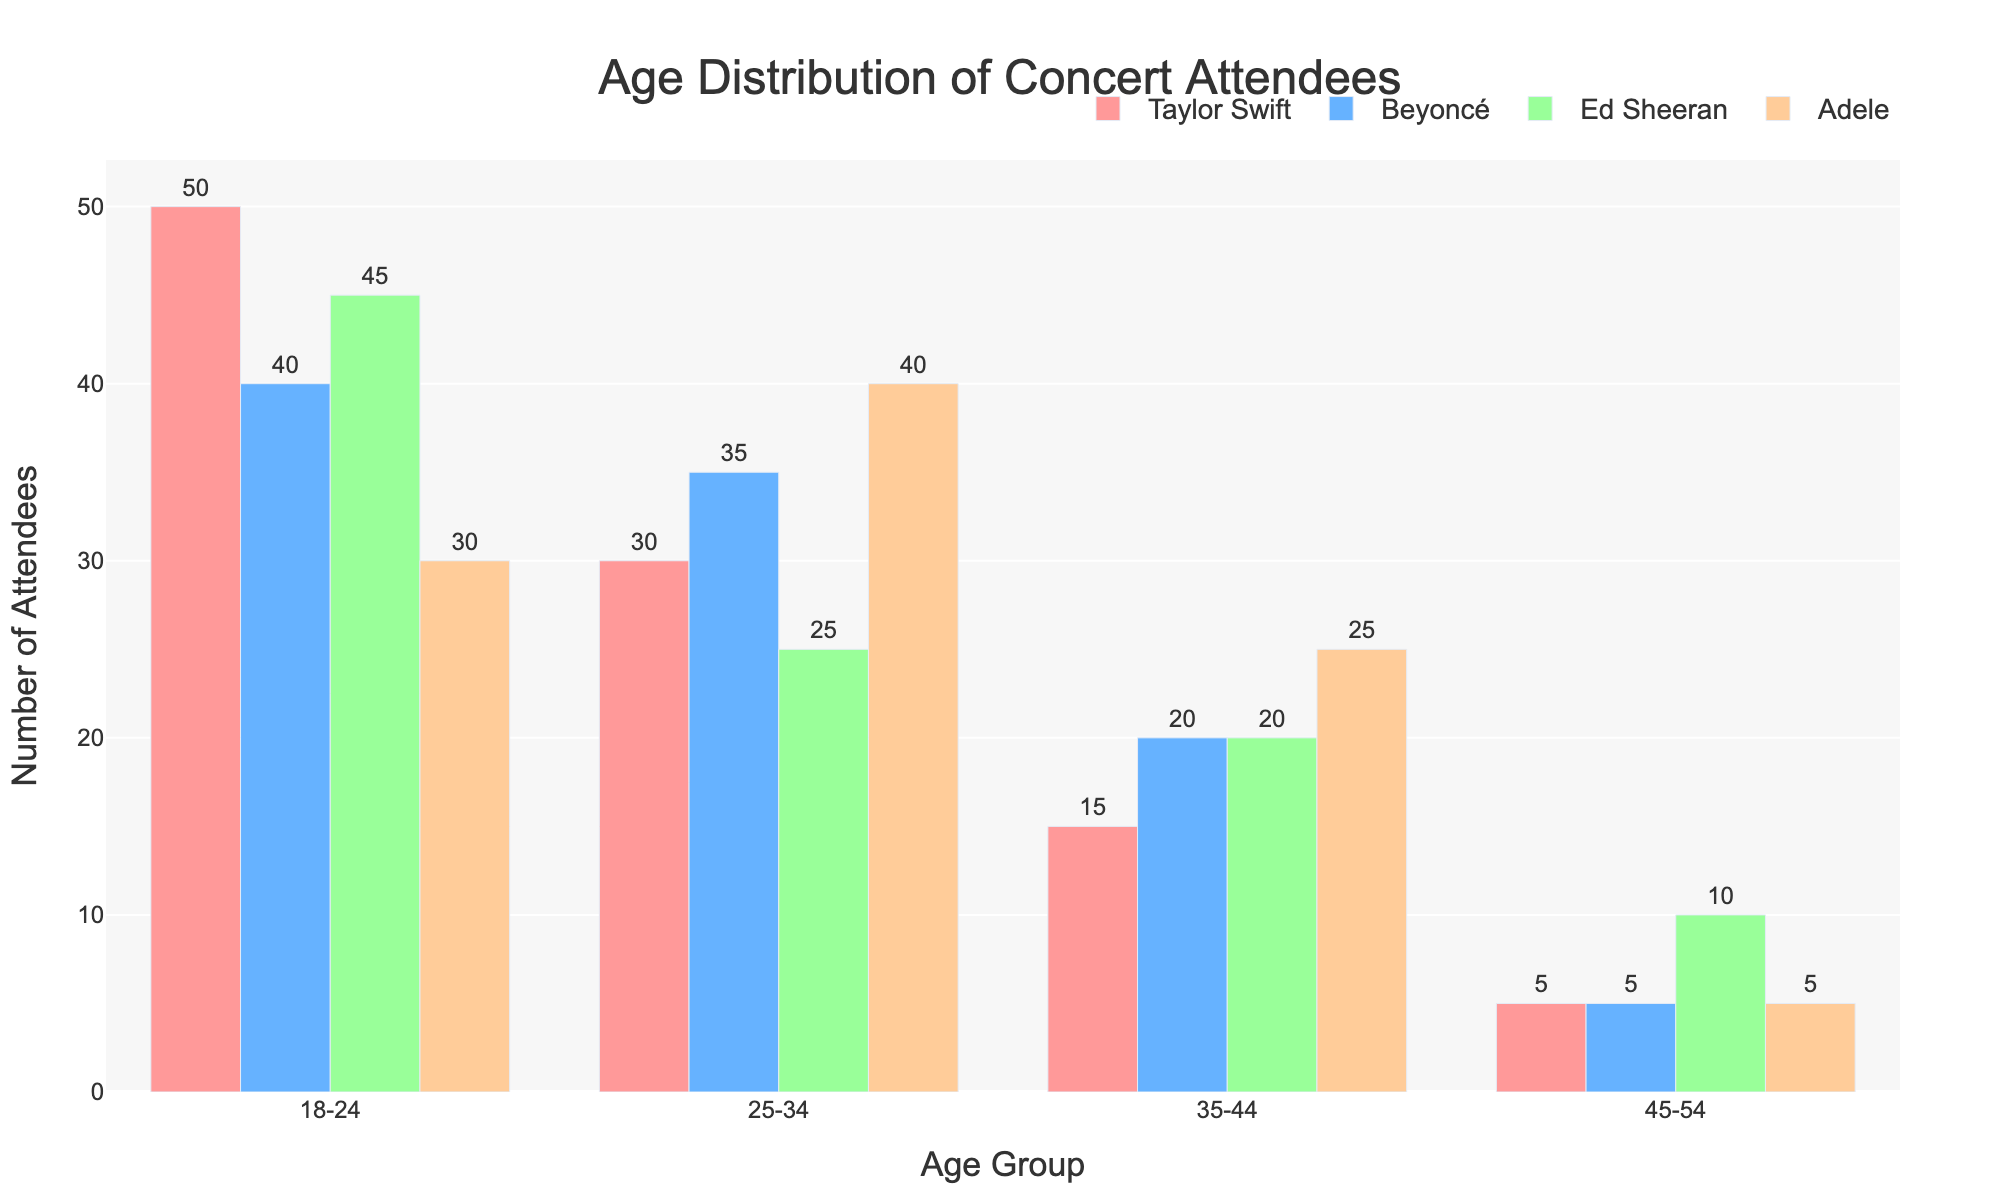How many attendees are in the 25-34 age group for Taylor Swift? Locate the bar corresponding to "Taylor Swift" and the "25-34" age group. The label on top of the bar shows the number of attendees.
Answer: 30 Which artist has the most attendees in the 18-24 age group? Compare the heights of the bars for the 18-24 age group among all artists. The artist with the tallest bar has the most attendees. Taylor Swift has the tallest bar in the 18-24 age group.
Answer: Taylor Swift What is the total number of attendees for Ed Sheeran? Sum the attendee numbers for Ed Sheeran across all age groups: 45 (18-24) + 25 (25-34) + 20 (35-44) + 10 (45-54).
Answer: 100 For which age group does Adele have the highest number of attendees? Identify the bar corresponding to Adele with the maximum height and check its age group. Adele has the highest bar in the 25-34 age group.
Answer: 25-34 Who has more attendees in the 35-44 age group, Beyoncé or Adele? Compare the heights of the 35-44 age group bars for both Beyoncé and Adele. Adele's bar is taller.
Answer: Adele Which artist has the lowest number of attendees overall? Sum up the attendees for each artist and compare. Taylor Swift: 50+30+15+5=100, Beyoncé: 40+35+20+5=100, Ed Sheeran: 45+25+20+10=100, Adele: 30+40+25+5=100. All artists have the same total number of attendees.
Answer: All artists How many attendees are there in the 45-54 age group for all artists combined? Add the numbers in the 45-54 age group for all artists: 5 (Taylor Swift) + 5 (Beyoncé) + 10 (Ed Sheeran) + 5 (Adele).
Answer: 25 What is the average number of attendees in the 25-34 age group across all artists? Calculate the sum of attendees in the 25-34 age group for all artists and divide by the number of artists: (30 + 35 + 25 + 40) / 4.
Answer: 32.5 Which artist has the highest total number of attendees in the 18-24 and 45-54 age groups combined? Add the numbers for the 18-24 and 45-54 age groups for each artist and compare. Taylor Swift: 50+5=55, Beyoncé: 40+5=45, Ed Sheeran: 45+10=55, Adele: 30+5=35. Both Taylor Swift and Ed Sheeran have the highest combined total.
Answer: Taylor Swift and Ed Sheeran For Beyoncé, what is the difference in attendees between the 18-24 and 35-44 age groups? Subtract the number of attendees in the 35-44 age group from the 18-24 age group for Beyoncé: 40 - 20.
Answer: 20 